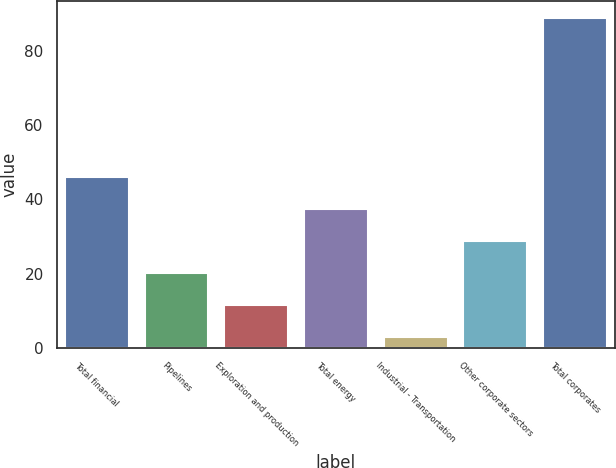Convert chart to OTSL. <chart><loc_0><loc_0><loc_500><loc_500><bar_chart><fcel>Total financial<fcel>Pipelines<fcel>Exploration and production<fcel>Total energy<fcel>Industrial - Transportation<fcel>Other corporate sectors<fcel>Total corporates<nl><fcel>46<fcel>20.2<fcel>11.6<fcel>37.4<fcel>3<fcel>28.8<fcel>89<nl></chart> 